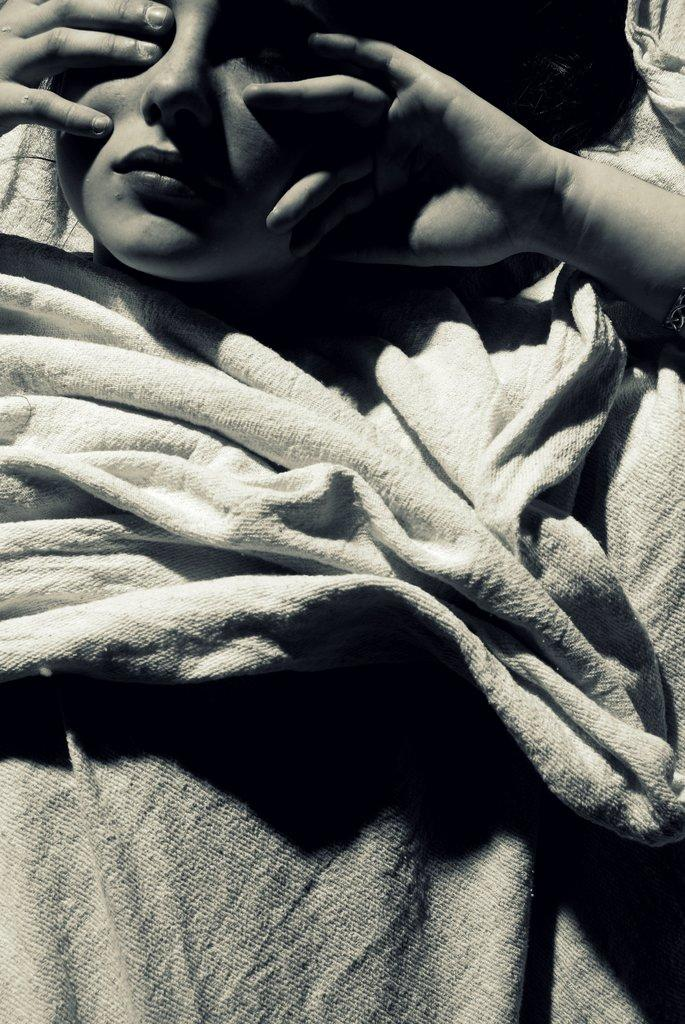What is the position of the person in the image? There is a person lying in the image. How is the other person in the image covered? There is a person covered with cloth in the image. What type of air is being used to shade the person in the image? There is no mention of air or shade in the image; it only shows two people, one lying and the other covered with cloth. 